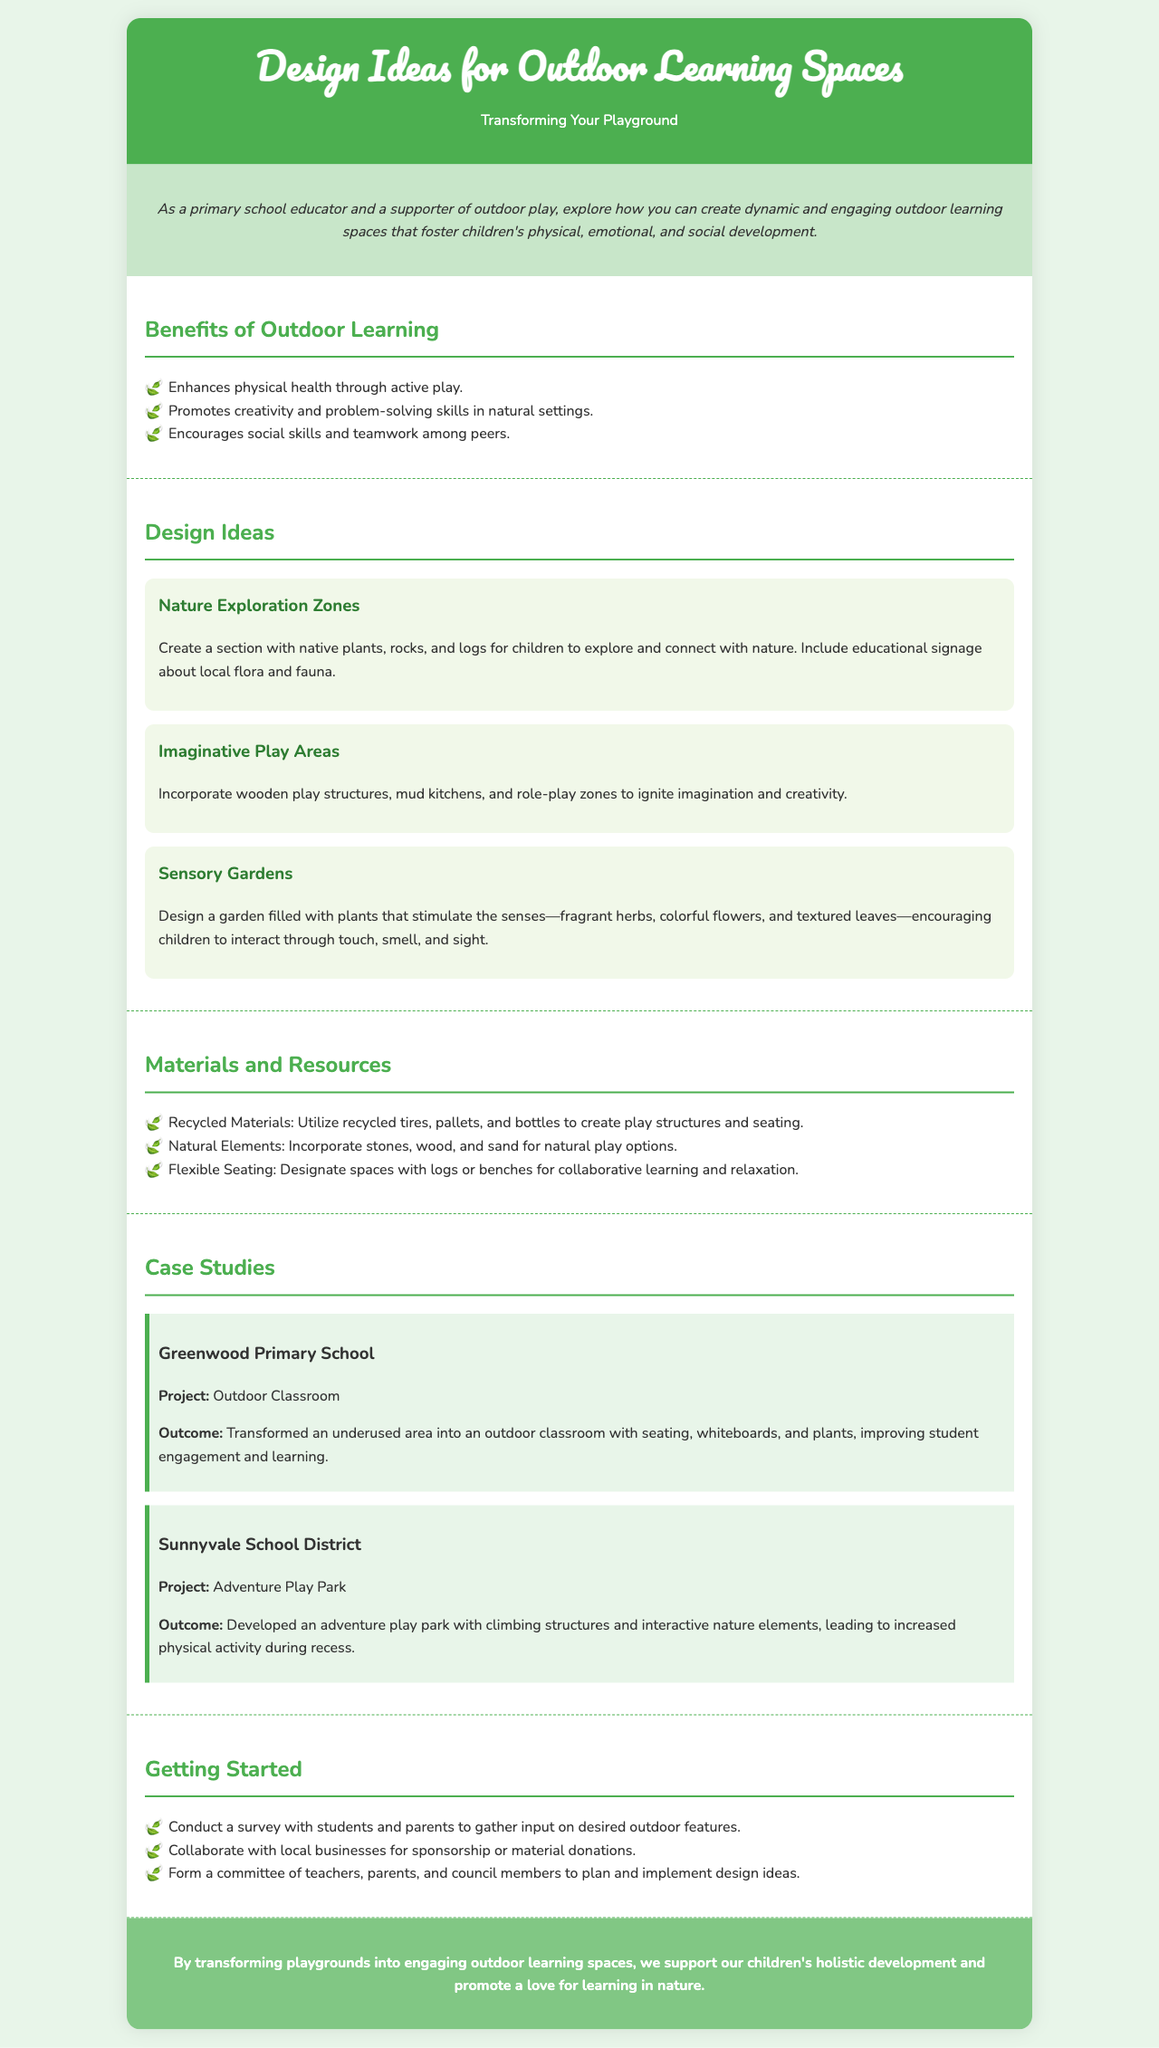what are the benefits of outdoor learning? The benefits section lists three key advantages of outdoor learning environments for children.
Answer: Enhances physical health through active play, Promotes creativity and problem-solving skills in natural settings, Encourages social skills and teamwork among peers which school developed an adventure play park? The case studies section highlights specific projects from different schools; this question seeks the name of the one with the adventure play park.
Answer: Sunnyvale School District what is one design idea for outdoor learning spaces? The design ideas section includes several strategies for creating engaging outdoor spaces; this prompt asks for any one of those design ideas.
Answer: Nature Exploration Zones (or Imaginative Play Areas, or Sensory Gardens) how can recycled materials be used in outdoor spaces? This question targets the materials section and their potential applications, specifically focusing on the use of recycled items.
Answer: Create play structures and seating what was the outcome for Greenwood Primary School's project? The case study for Greenwood Primary School states the results of their outdoor classroom project; this question requires summarizing that outcome.
Answer: Improving student engagement and learning how can a committee be formed for planning outdoor spaces? This question refers to the steps for getting started, focusing on how to form a committee for outdoor space planning.
Answer: Teachers, parents, and council members what is included in a sensory garden? The design ideas section provides details about specific themes; this question seeks to identify components of sensory gardens mentioned in the section.
Answer: Plants that stimulate the senses—fragrant herbs, colorful flowers, and textured leaves 